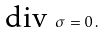<formula> <loc_0><loc_0><loc_500><loc_500>\text {div } \sigma = 0 \, .</formula> 